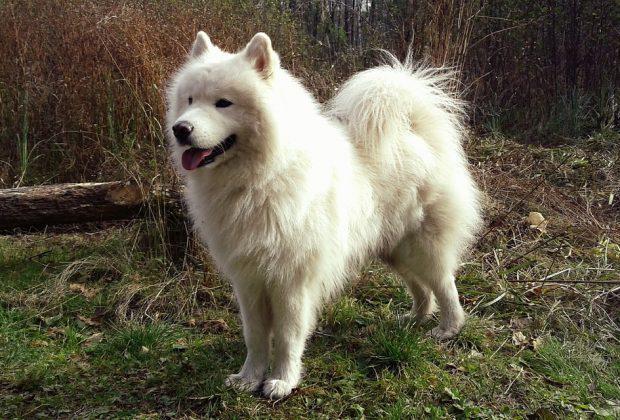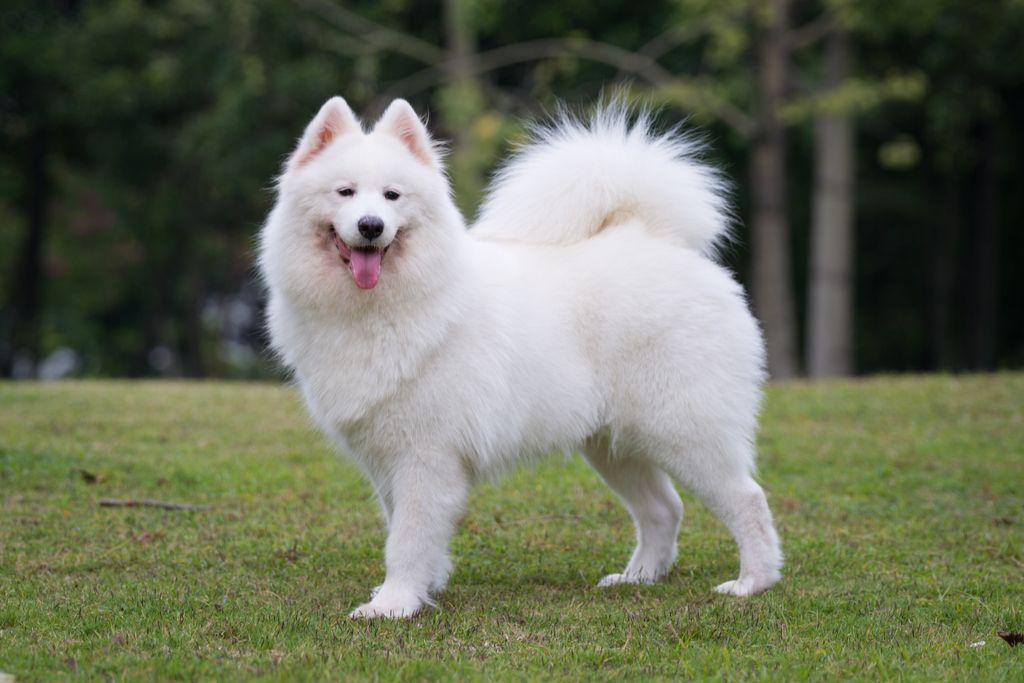The first image is the image on the left, the second image is the image on the right. Assess this claim about the two images: "All dogs face the same direction, and all dogs are standing on all fours.". Correct or not? Answer yes or no. Yes. The first image is the image on the left, the second image is the image on the right. For the images displayed, is the sentence "At least one dog is lying down in the image on the left." factually correct? Answer yes or no. No. 